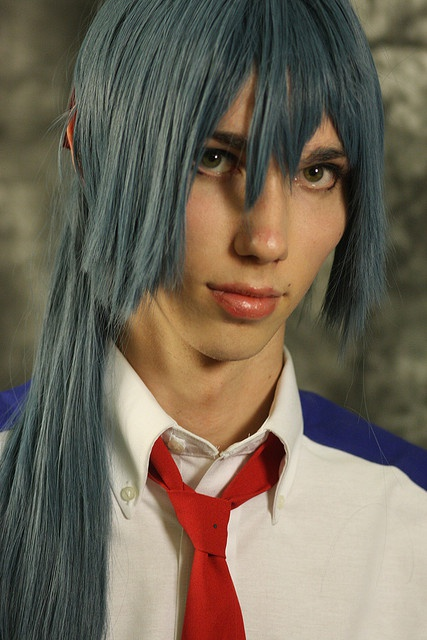Describe the objects in this image and their specific colors. I can see people in darkgreen, gray, black, lightgray, and tan tones and tie in darkgreen, brown, and maroon tones in this image. 